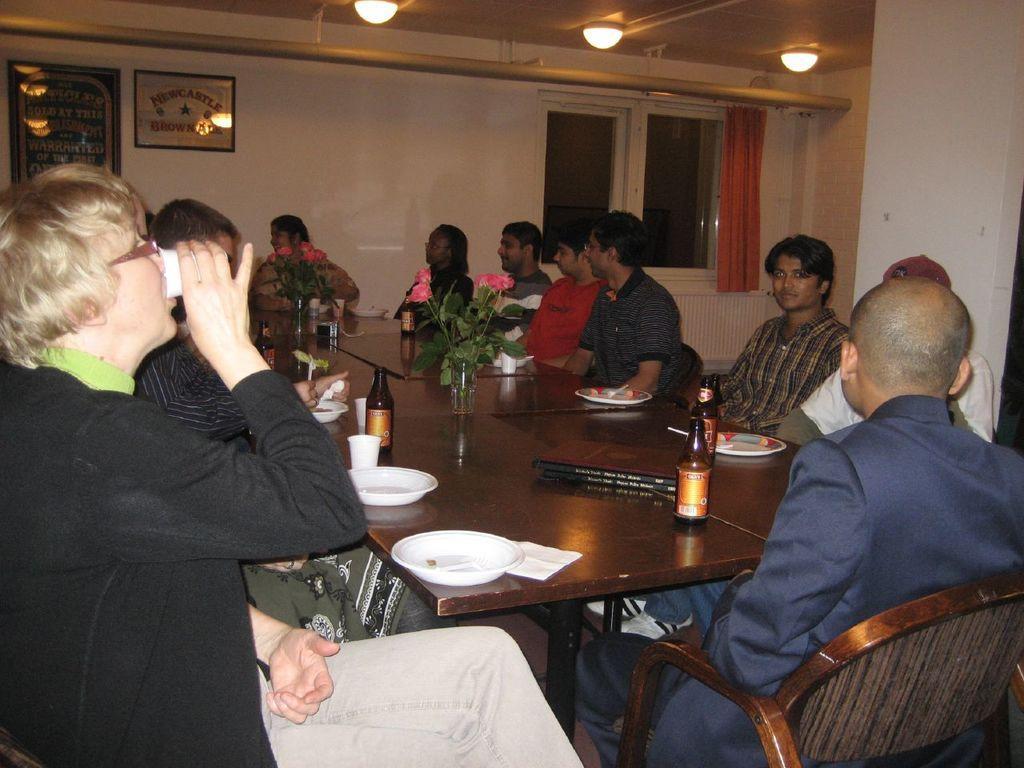In one or two sentences, can you explain what this image depicts? In this image there are group of people sitting on the chair. On the table there is plate,bottle and a flower vase. The frame are attached to the wall. There is a curtain and a window. 